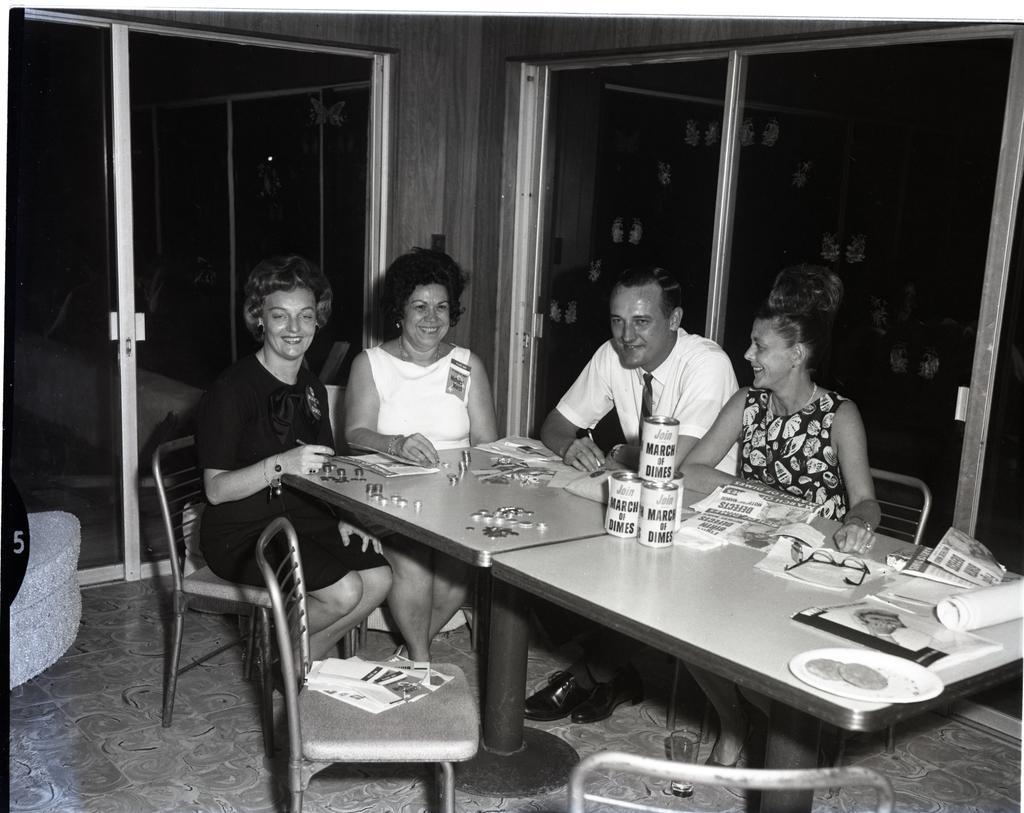How would you summarize this image in a sentence or two? In this picture we can see three woman and one men sitting on chair and smiling and in front of them on table we have coins, tins, spectacle, papers, chart, book, plate with food in it and in background we can see windows. 